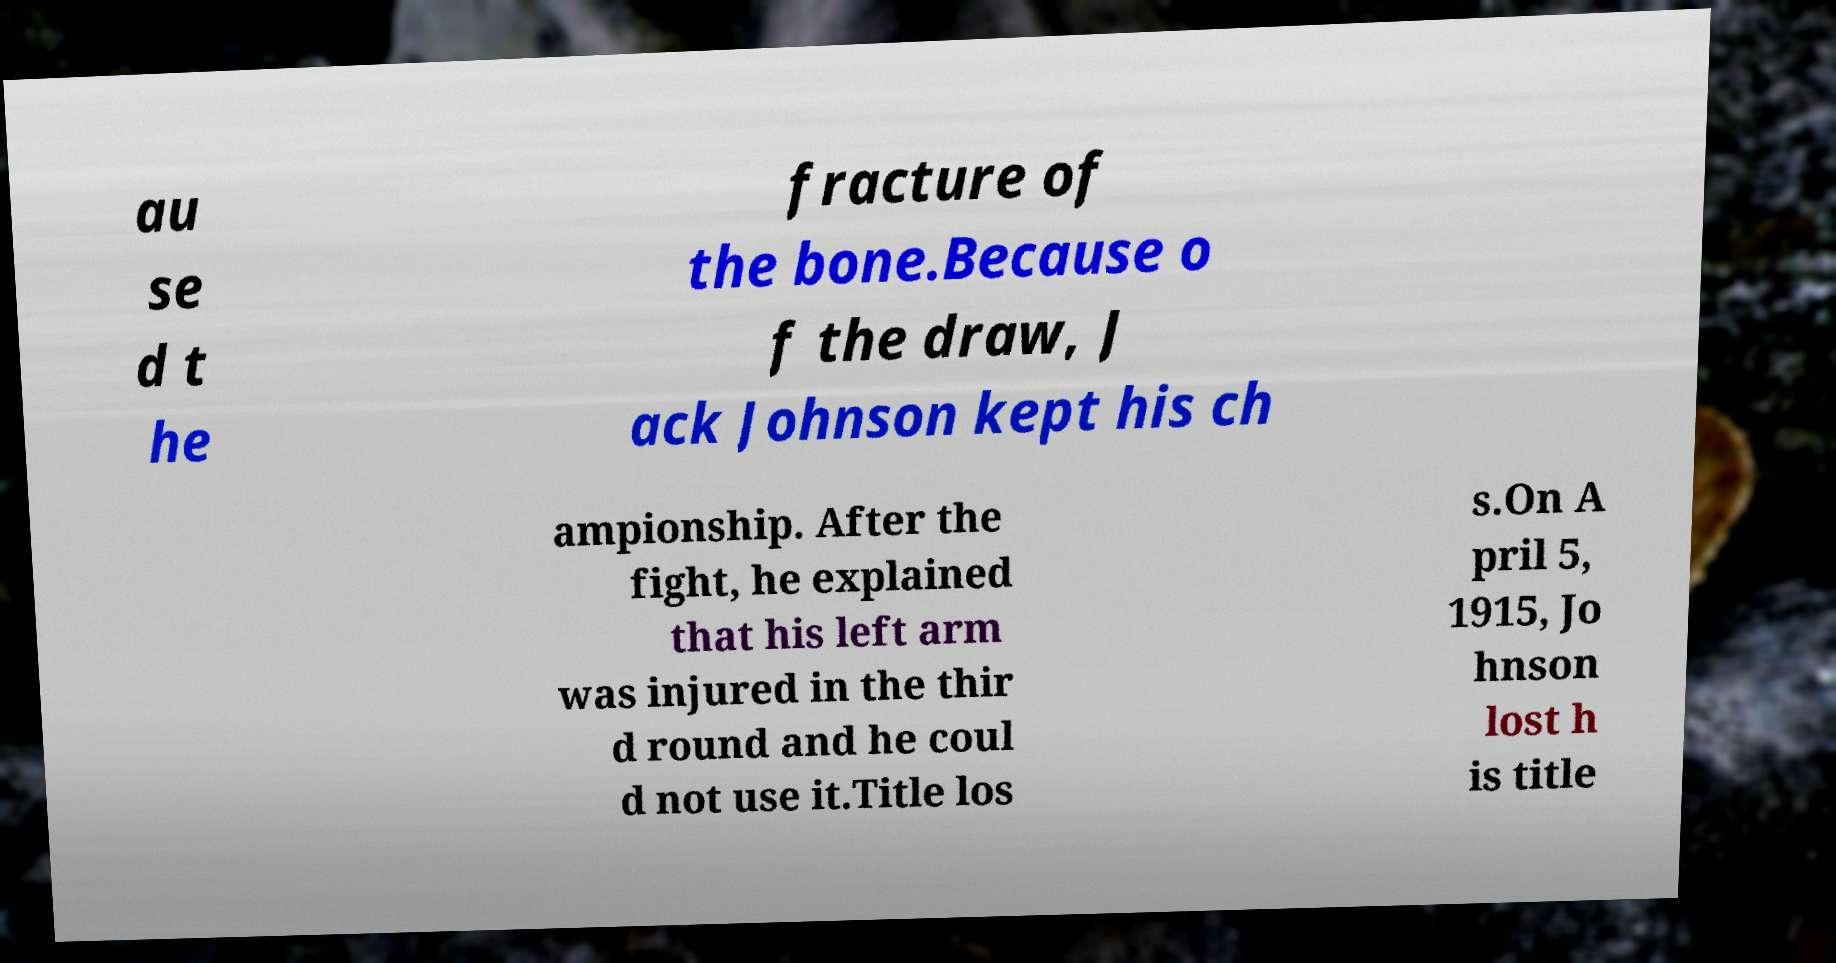What messages or text are displayed in this image? I need them in a readable, typed format. au se d t he fracture of the bone.Because o f the draw, J ack Johnson kept his ch ampionship. After the fight, he explained that his left arm was injured in the thir d round and he coul d not use it.Title los s.On A pril 5, 1915, Jo hnson lost h is title 